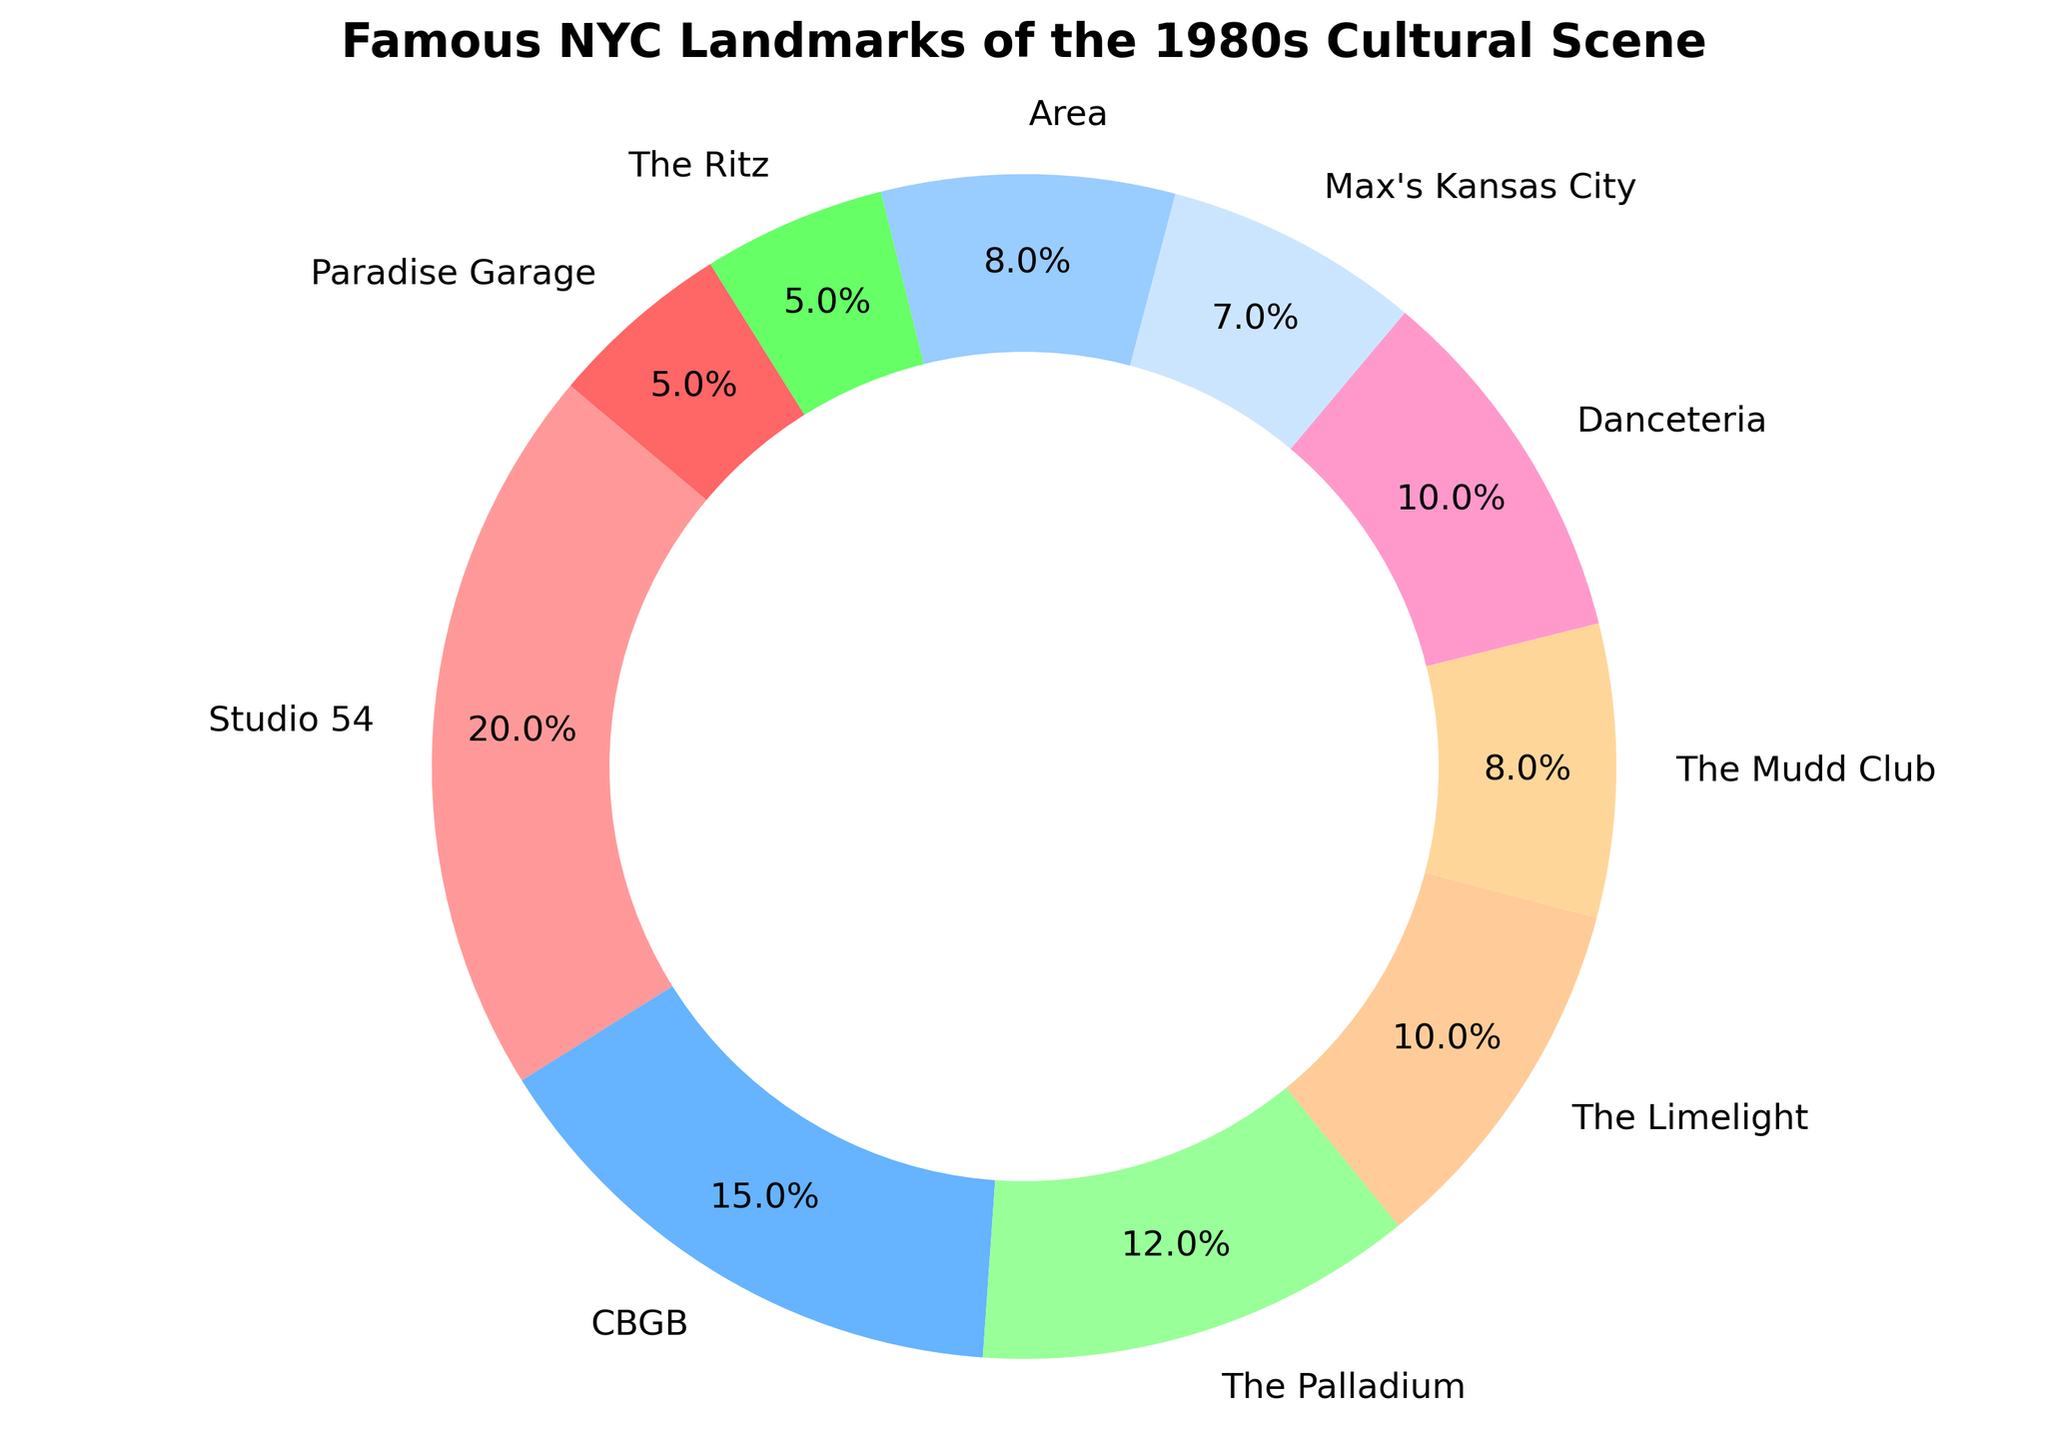What is the largest slice in the pie chart? The largest slice represents the landmark with the highest percentage. By looking at the figure, we see that "Studio 54" occupies the largest segment of the pie chart.
Answer: Studio 54 What percentage of the pie chart is shared by The Ritz and Paradise Garage combined? To find the combined percentage of The Ritz and Paradise Garage, sum their respective percentages from the chart: 5% + 5%. Therefore, the combined percentage is 10%.
Answer: 10% Which landmark has a higher percentage: The Limelight or The Palladium? By comparing the two landmarks' percentages in the chart, The Palladium has 12%, and The Limelight has 10%. Hence, The Palladium has a higher percentage.
Answer: The Palladium Which color represents CBGB in the pie chart? Each segment in the pie chart is labeled with the name of the landmark and has a specific color. By checking the label of CBGB and its associated color, we can identify the color.
Answer: Blue (assuming it follows the color order provided) What is the combined percentage for the landmarks Studio 54, Area, and Danceteria? Add the percentages for Studio 54 (20%), Area (8%), and Danceteria (10%) to obtain the combined total. Thus, 20% + 8% + 10% equals 38%.
Answer: 38% Are there any landmarks with the same percentage value in the chart? By examining the chart, we notice that The Ritz and Paradise Garage both have slices indicating 5%. Therefore, they have the same percentage value.
Answer: Yes, The Ritz and Paradise Garage What is the smallest slice in the pie chart? By observing the figure, the smallest slice is the one with the smallest percentage. Max's Kansas City is represented with 7%, which is the smallest percentage on the chart.
Answer: Max's Kansas City Is the percentage of The Mudd Club greater than the percentage of Area? Comparing the percentages from the figure, The Mudd Club has 8%, and Area also has 8%. Therefore, neither is greater than the other; they are equal.
Answer: No, they are equal What is the total percentage represented by The Palladium, The Limelight, and The Mudd Club? Summing the percentages for The Palladium (12%), The Limelight (10%), and The Mudd Club (8%) gives a total of 12% + 10% + 8%, which sums to 30%.
Answer: 30% Which landmark is represented by the color associated with the second-largest slice? Identifying the second-largest slice visually, we see it corresponds to CBGB, which occupies 15% of the chart.
Answer: CBGB 